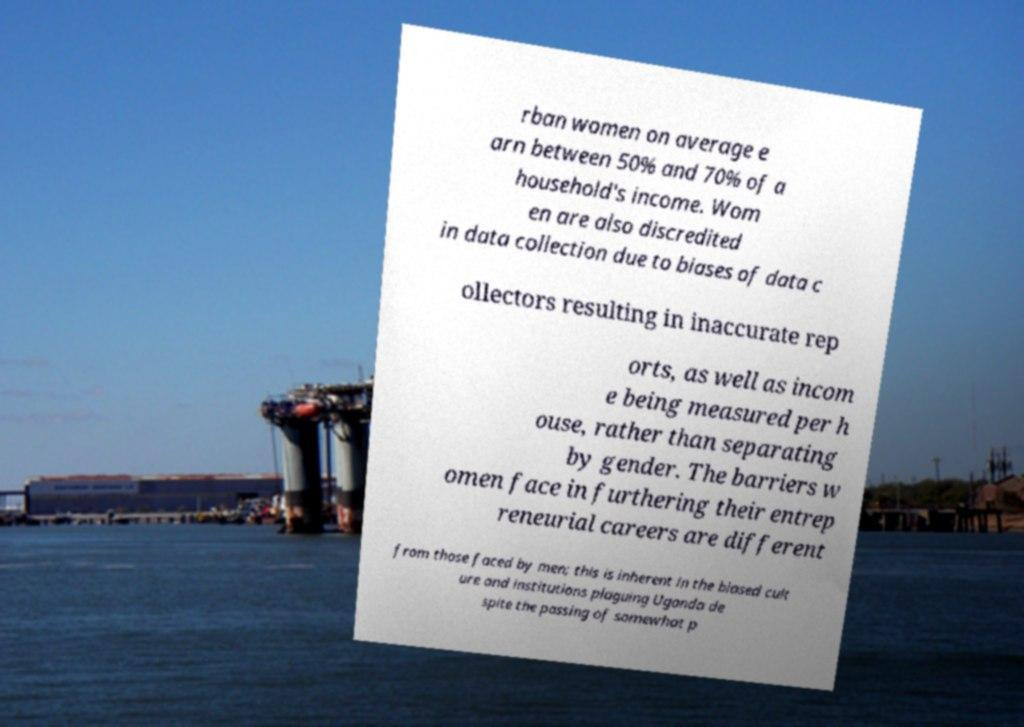For documentation purposes, I need the text within this image transcribed. Could you provide that? rban women on average e arn between 50% and 70% of a household's income. Wom en are also discredited in data collection due to biases of data c ollectors resulting in inaccurate rep orts, as well as incom e being measured per h ouse, rather than separating by gender. The barriers w omen face in furthering their entrep reneurial careers are different from those faced by men; this is inherent in the biased cult ure and institutions plaguing Uganda de spite the passing of somewhat p 